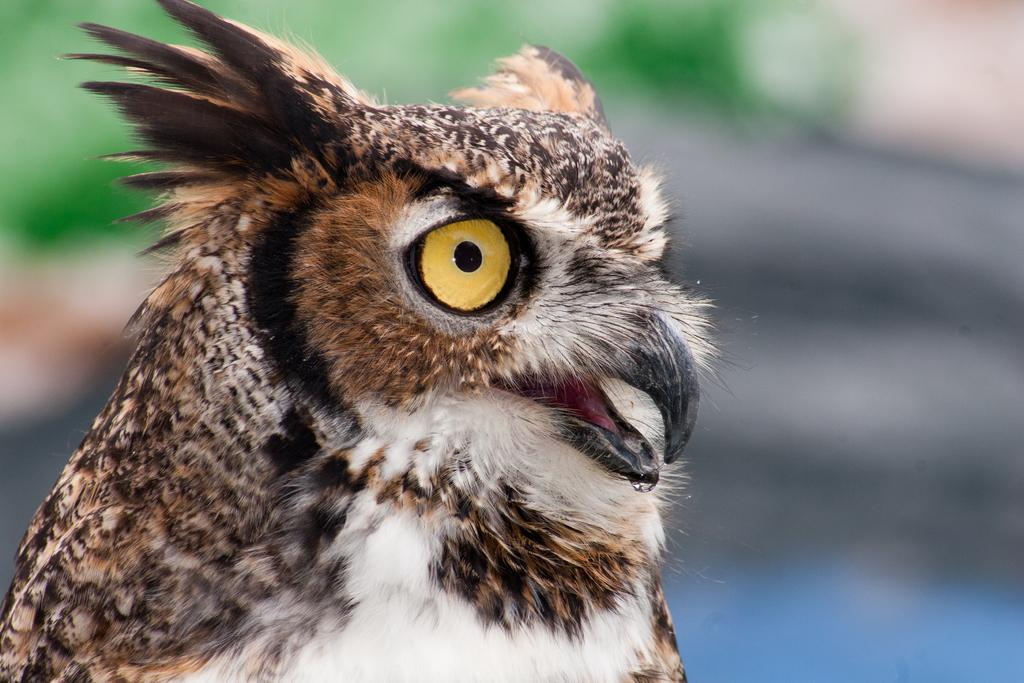What type of animal is in the image? There is an owl in the image. What type of lettuce is the owl eating in the image? There is no lettuce present in the image, and the owl is not shown eating anything. 